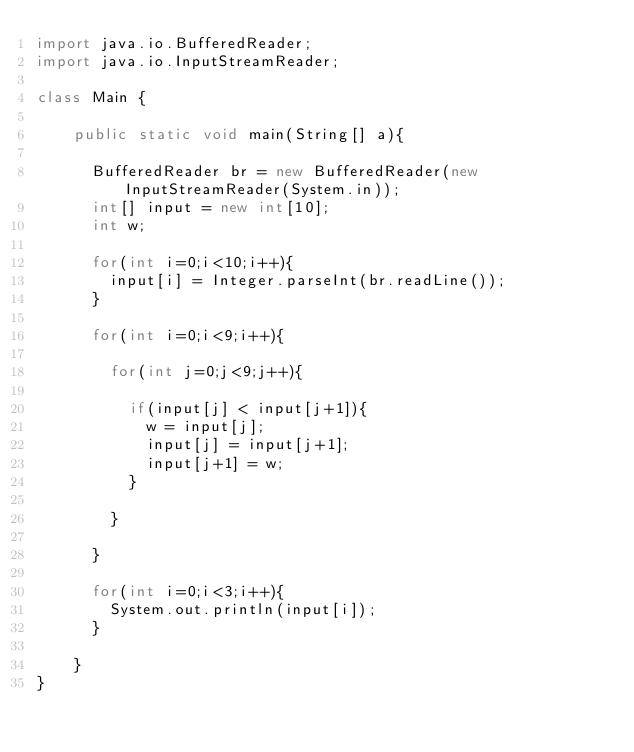<code> <loc_0><loc_0><loc_500><loc_500><_Java_>import java.io.BufferedReader;
import java.io.InputStreamReader;

class Main {

    public static void main(String[] a){

    	BufferedReader br = new BufferedReader(new InputStreamReader(System.in));
    	int[] input = new int[10];
    	int w;

    	for(int i=0;i<10;i++){
    		input[i] = Integer.parseInt(br.readLine());
    	}

    	for(int i=0;i<9;i++){

    		for(int j=0;j<9;j++){

    			if(input[j] < input[j+1]){
    				w = input[j];
    				input[j] = input[j+1];
    				input[j+1] = w;
    			}

    		}

    	}

    	for(int i=0;i<3;i++){
    		System.out.println(input[i]);
    	}

    }
}</code> 